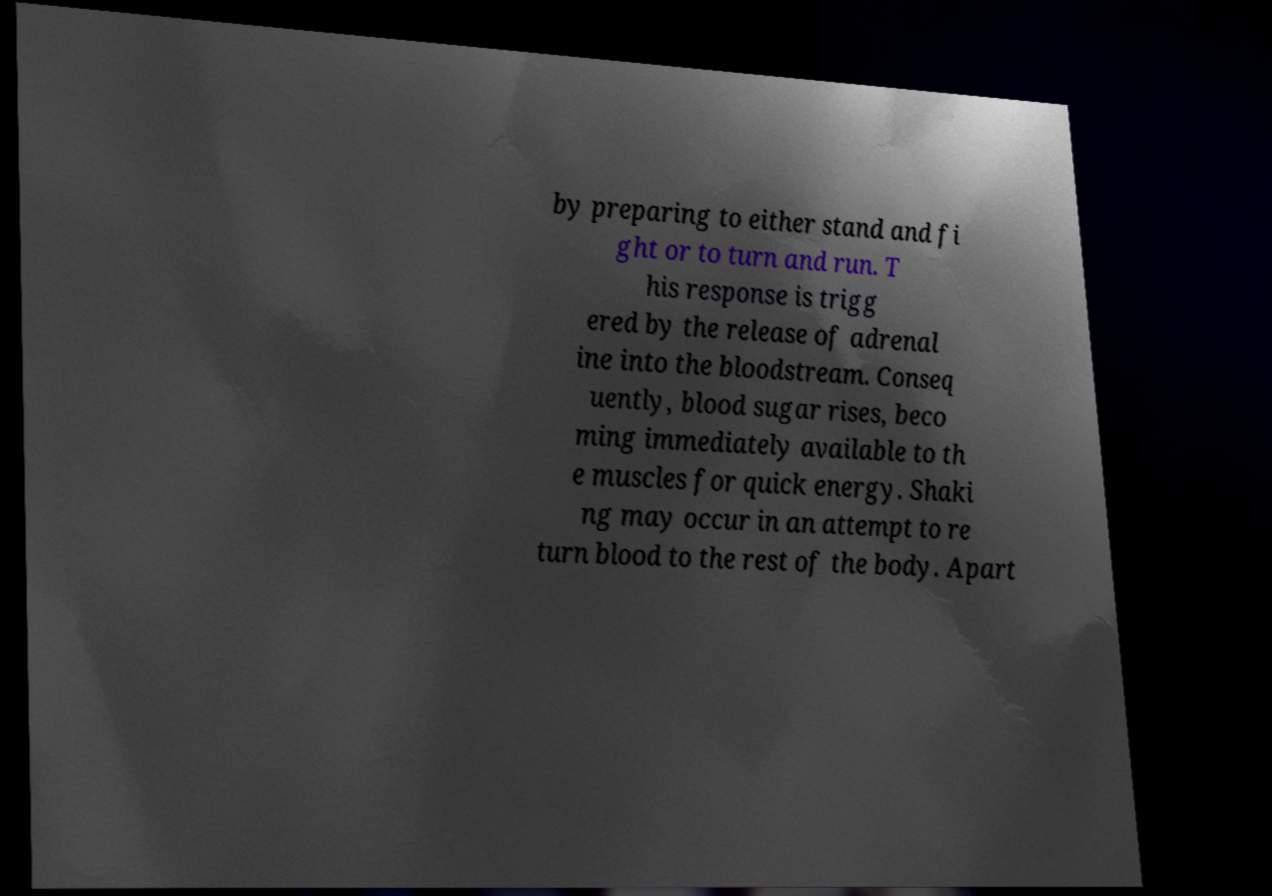I need the written content from this picture converted into text. Can you do that? by preparing to either stand and fi ght or to turn and run. T his response is trigg ered by the release of adrenal ine into the bloodstream. Conseq uently, blood sugar rises, beco ming immediately available to th e muscles for quick energy. Shaki ng may occur in an attempt to re turn blood to the rest of the body. Apart 